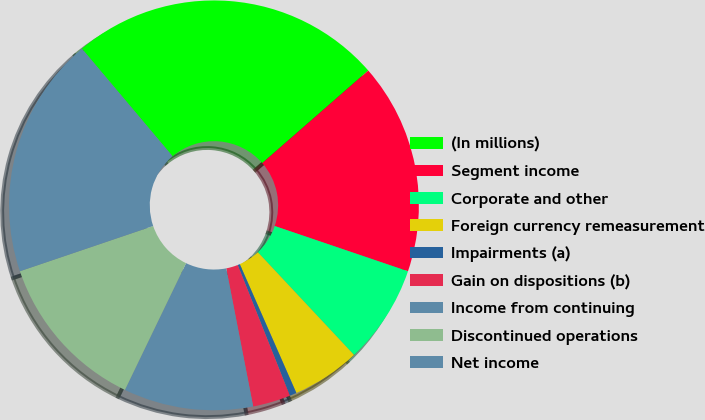<chart> <loc_0><loc_0><loc_500><loc_500><pie_chart><fcel>(In millions)<fcel>Segment income<fcel>Corporate and other<fcel>Foreign currency remeasurement<fcel>Impairments (a)<fcel>Gain on dispositions (b)<fcel>Income from continuing<fcel>Discontinued operations<fcel>Net income<nl><fcel>24.72%<fcel>16.64%<fcel>7.81%<fcel>5.39%<fcel>0.55%<fcel>2.97%<fcel>10.22%<fcel>12.64%<fcel>19.06%<nl></chart> 